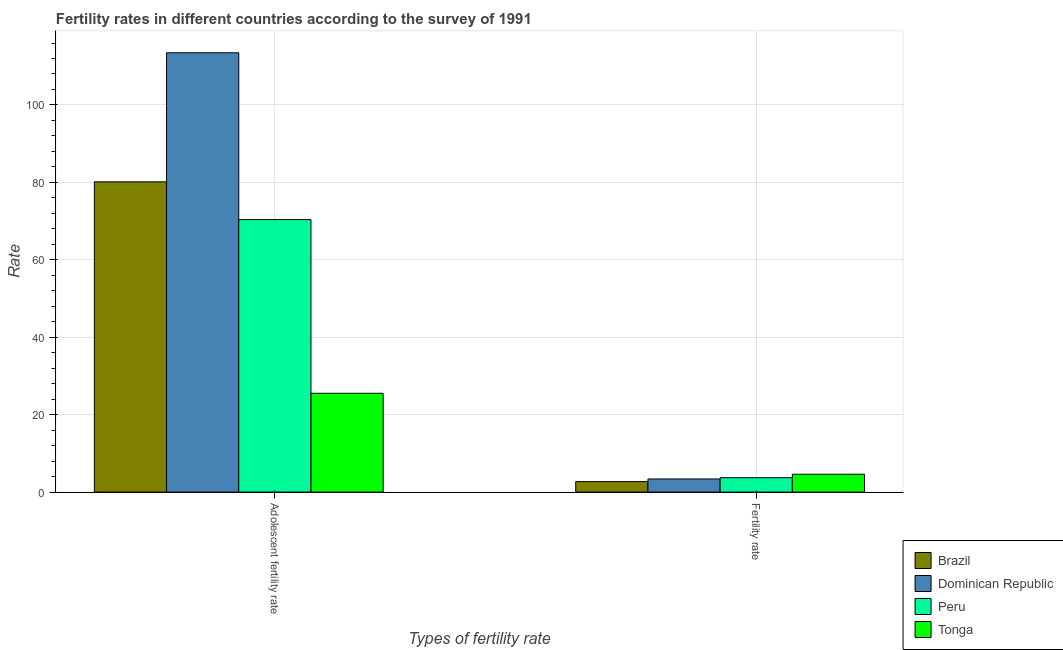How many different coloured bars are there?
Make the answer very short. 4. Are the number of bars per tick equal to the number of legend labels?
Offer a very short reply. Yes. Are the number of bars on each tick of the X-axis equal?
Your response must be concise. Yes. How many bars are there on the 2nd tick from the right?
Your answer should be very brief. 4. What is the label of the 2nd group of bars from the left?
Your response must be concise. Fertility rate. What is the fertility rate in Tonga?
Your answer should be compact. 4.61. Across all countries, what is the maximum adolescent fertility rate?
Provide a succinct answer. 113.48. Across all countries, what is the minimum fertility rate?
Offer a terse response. 2.72. In which country was the adolescent fertility rate maximum?
Ensure brevity in your answer.  Dominican Republic. In which country was the adolescent fertility rate minimum?
Keep it short and to the point. Tonga. What is the total fertility rate in the graph?
Give a very brief answer. 14.45. What is the difference between the adolescent fertility rate in Peru and that in Tonga?
Keep it short and to the point. 44.87. What is the difference between the fertility rate in Peru and the adolescent fertility rate in Tonga?
Offer a terse response. -21.8. What is the average adolescent fertility rate per country?
Provide a succinct answer. 72.39. What is the difference between the adolescent fertility rate and fertility rate in Tonga?
Offer a very short reply. 20.91. What is the ratio of the fertility rate in Brazil to that in Peru?
Give a very brief answer. 0.73. What does the 2nd bar from the left in Adolescent fertility rate represents?
Make the answer very short. Dominican Republic. What does the 4th bar from the right in Adolescent fertility rate represents?
Offer a very short reply. Brazil. Are all the bars in the graph horizontal?
Give a very brief answer. No. Does the graph contain any zero values?
Your response must be concise. No. Does the graph contain grids?
Offer a terse response. Yes. Where does the legend appear in the graph?
Provide a succinct answer. Bottom right. How many legend labels are there?
Give a very brief answer. 4. What is the title of the graph?
Your answer should be compact. Fertility rates in different countries according to the survey of 1991. What is the label or title of the X-axis?
Ensure brevity in your answer.  Types of fertility rate. What is the label or title of the Y-axis?
Make the answer very short. Rate. What is the Rate of Brazil in Adolescent fertility rate?
Ensure brevity in your answer.  80.15. What is the Rate in Dominican Republic in Adolescent fertility rate?
Offer a very short reply. 113.48. What is the Rate in Peru in Adolescent fertility rate?
Provide a short and direct response. 70.4. What is the Rate of Tonga in Adolescent fertility rate?
Provide a succinct answer. 25.52. What is the Rate in Brazil in Fertility rate?
Your answer should be very brief. 2.72. What is the Rate of Dominican Republic in Fertility rate?
Provide a short and direct response. 3.4. What is the Rate of Peru in Fertility rate?
Your response must be concise. 3.72. What is the Rate in Tonga in Fertility rate?
Ensure brevity in your answer.  4.61. Across all Types of fertility rate, what is the maximum Rate of Brazil?
Provide a short and direct response. 80.15. Across all Types of fertility rate, what is the maximum Rate in Dominican Republic?
Ensure brevity in your answer.  113.48. Across all Types of fertility rate, what is the maximum Rate in Peru?
Your answer should be compact. 70.4. Across all Types of fertility rate, what is the maximum Rate of Tonga?
Your response must be concise. 25.52. Across all Types of fertility rate, what is the minimum Rate of Brazil?
Make the answer very short. 2.72. Across all Types of fertility rate, what is the minimum Rate of Dominican Republic?
Ensure brevity in your answer.  3.4. Across all Types of fertility rate, what is the minimum Rate of Peru?
Provide a short and direct response. 3.72. Across all Types of fertility rate, what is the minimum Rate of Tonga?
Your response must be concise. 4.61. What is the total Rate of Brazil in the graph?
Provide a succinct answer. 82.87. What is the total Rate in Dominican Republic in the graph?
Ensure brevity in your answer.  116.87. What is the total Rate in Peru in the graph?
Your answer should be very brief. 74.12. What is the total Rate of Tonga in the graph?
Your response must be concise. 30.14. What is the difference between the Rate of Brazil in Adolescent fertility rate and that in Fertility rate?
Your response must be concise. 77.43. What is the difference between the Rate in Dominican Republic in Adolescent fertility rate and that in Fertility rate?
Ensure brevity in your answer.  110.08. What is the difference between the Rate in Peru in Adolescent fertility rate and that in Fertility rate?
Offer a terse response. 66.68. What is the difference between the Rate in Tonga in Adolescent fertility rate and that in Fertility rate?
Keep it short and to the point. 20.91. What is the difference between the Rate of Brazil in Adolescent fertility rate and the Rate of Dominican Republic in Fertility rate?
Your response must be concise. 76.75. What is the difference between the Rate in Brazil in Adolescent fertility rate and the Rate in Peru in Fertility rate?
Keep it short and to the point. 76.43. What is the difference between the Rate in Brazil in Adolescent fertility rate and the Rate in Tonga in Fertility rate?
Offer a terse response. 75.54. What is the difference between the Rate of Dominican Republic in Adolescent fertility rate and the Rate of Peru in Fertility rate?
Provide a succinct answer. 109.76. What is the difference between the Rate in Dominican Republic in Adolescent fertility rate and the Rate in Tonga in Fertility rate?
Your response must be concise. 108.87. What is the difference between the Rate of Peru in Adolescent fertility rate and the Rate of Tonga in Fertility rate?
Make the answer very short. 65.79. What is the average Rate of Brazil per Types of fertility rate?
Make the answer very short. 41.43. What is the average Rate of Dominican Republic per Types of fertility rate?
Offer a terse response. 58.44. What is the average Rate of Peru per Types of fertility rate?
Offer a terse response. 37.06. What is the average Rate of Tonga per Types of fertility rate?
Provide a short and direct response. 15.07. What is the difference between the Rate of Brazil and Rate of Dominican Republic in Adolescent fertility rate?
Give a very brief answer. -33.33. What is the difference between the Rate in Brazil and Rate in Peru in Adolescent fertility rate?
Provide a succinct answer. 9.75. What is the difference between the Rate in Brazil and Rate in Tonga in Adolescent fertility rate?
Give a very brief answer. 54.62. What is the difference between the Rate of Dominican Republic and Rate of Peru in Adolescent fertility rate?
Make the answer very short. 43.08. What is the difference between the Rate in Dominican Republic and Rate in Tonga in Adolescent fertility rate?
Your answer should be compact. 87.95. What is the difference between the Rate in Peru and Rate in Tonga in Adolescent fertility rate?
Keep it short and to the point. 44.87. What is the difference between the Rate in Brazil and Rate in Dominican Republic in Fertility rate?
Keep it short and to the point. -0.68. What is the difference between the Rate in Brazil and Rate in Peru in Fertility rate?
Offer a terse response. -1. What is the difference between the Rate in Brazil and Rate in Tonga in Fertility rate?
Your answer should be very brief. -1.9. What is the difference between the Rate in Dominican Republic and Rate in Peru in Fertility rate?
Offer a very short reply. -0.33. What is the difference between the Rate of Dominican Republic and Rate of Tonga in Fertility rate?
Offer a very short reply. -1.22. What is the difference between the Rate of Peru and Rate of Tonga in Fertility rate?
Provide a short and direct response. -0.89. What is the ratio of the Rate of Brazil in Adolescent fertility rate to that in Fertility rate?
Your answer should be compact. 29.5. What is the ratio of the Rate of Dominican Republic in Adolescent fertility rate to that in Fertility rate?
Provide a short and direct response. 33.41. What is the ratio of the Rate in Peru in Adolescent fertility rate to that in Fertility rate?
Ensure brevity in your answer.  18.91. What is the ratio of the Rate in Tonga in Adolescent fertility rate to that in Fertility rate?
Offer a very short reply. 5.53. What is the difference between the highest and the second highest Rate in Brazil?
Keep it short and to the point. 77.43. What is the difference between the highest and the second highest Rate of Dominican Republic?
Provide a succinct answer. 110.08. What is the difference between the highest and the second highest Rate in Peru?
Offer a terse response. 66.68. What is the difference between the highest and the second highest Rate of Tonga?
Provide a succinct answer. 20.91. What is the difference between the highest and the lowest Rate of Brazil?
Offer a terse response. 77.43. What is the difference between the highest and the lowest Rate of Dominican Republic?
Keep it short and to the point. 110.08. What is the difference between the highest and the lowest Rate in Peru?
Keep it short and to the point. 66.68. What is the difference between the highest and the lowest Rate of Tonga?
Offer a terse response. 20.91. 